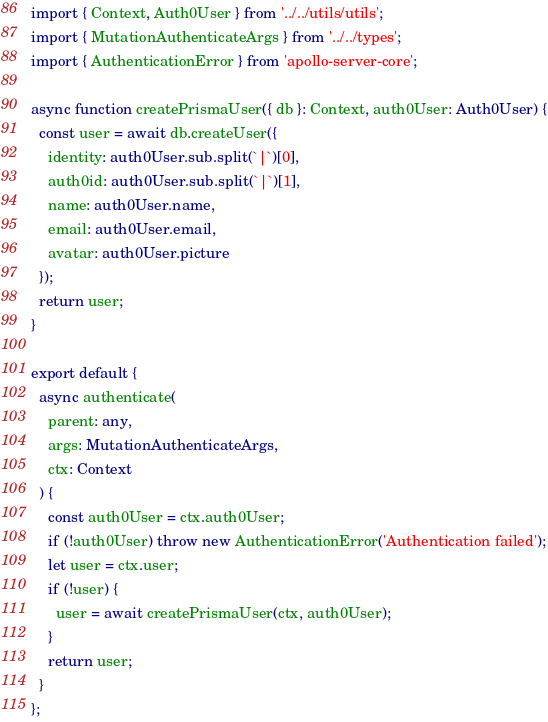Convert code to text. <code><loc_0><loc_0><loc_500><loc_500><_TypeScript_>import { Context, Auth0User } from '../../utils/utils';
import { MutationAuthenticateArgs } from '../../types';
import { AuthenticationError } from 'apollo-server-core';

async function createPrismaUser({ db }: Context, auth0User: Auth0User) {
  const user = await db.createUser({
    identity: auth0User.sub.split(`|`)[0],
    auth0id: auth0User.sub.split(`|`)[1],
    name: auth0User.name,
    email: auth0User.email,
    avatar: auth0User.picture
  });
  return user;
}

export default {
  async authenticate(
    parent: any,
    args: MutationAuthenticateArgs,
    ctx: Context
  ) {
    const auth0User = ctx.auth0User;
    if (!auth0User) throw new AuthenticationError('Authentication failed');
    let user = ctx.user;
    if (!user) {
      user = await createPrismaUser(ctx, auth0User);
    }
    return user;
  }
};
</code> 